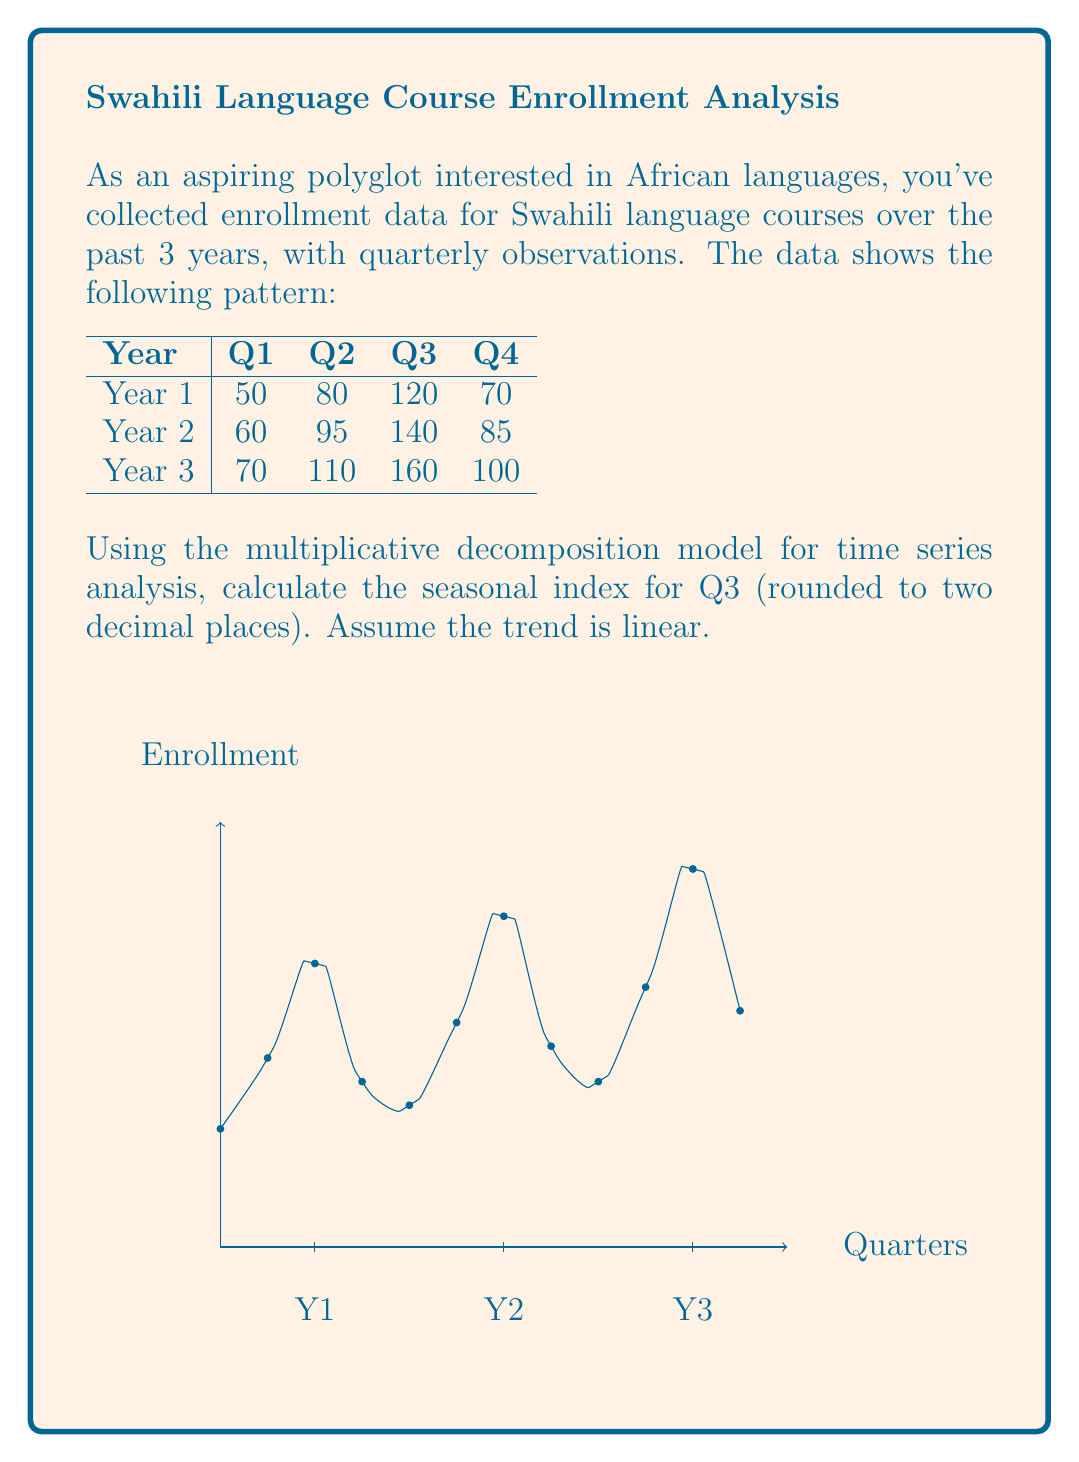What is the answer to this math problem? To calculate the seasonal index for Q3 using the multiplicative decomposition model, we'll follow these steps:

1) First, calculate the centered moving average (CMA) to estimate the trend-cycle component:
   $$CMA_t = \frac{1}{4}(0.5Y_{t-2} + Y_{t-1} + Y_t + Y_{t+1} + 0.5Y_{t+2})$$

   For Q3 of each year:
   Year 1: $CMA_5 = \frac{1}{4}(0.5(50) + 80 + 120 + 70 + 0.5(60)) = 82.5$
   Year 2: $CMA_9 = \frac{1}{4}(0.5(60) + 95 + 140 + 85 + 0.5(70)) = 100$
   Year 3: $CMA_{13} = \frac{1}{4}(0.5(70) + 110 + 160 + 100 + 0.5(70)) = 117.5$

2) Calculate the seasonal-irregular ratios by dividing the original values by the CMA:
   Year 1: $120 / 82.5 = 1.4545$
   Year 2: $140 / 100 = 1.4000$
   Year 3: $160 / 117.5 = 1.3617$

3) The seasonal index for Q3 is the average of these ratios:
   $$SI_{Q3} = \frac{1.4545 + 1.4000 + 1.3617}{3} = 1.4054$$

4) Rounding to two decimal places: 1.41

This means that enrollment in Q3 is typically 41% higher than the trend value for that quarter.
Answer: 1.41 